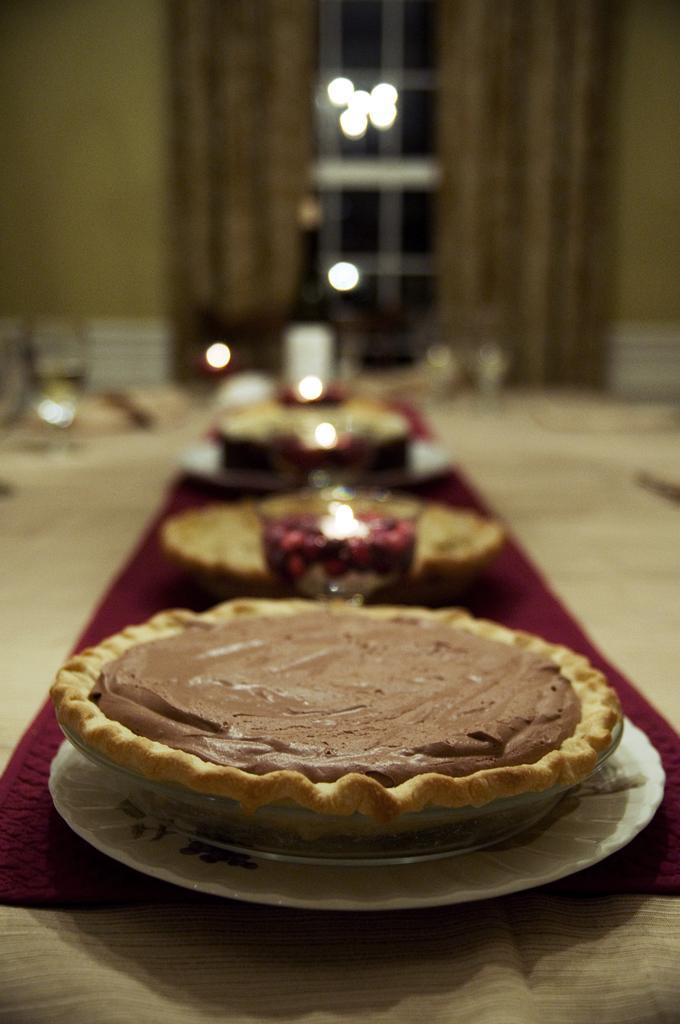Could you give a brief overview of what you see in this image? In this picture, we see a dining table on which plates containing food and glasses containing liquids are placed. In the background, we see a window, curtains and a wall. It is blurred in the background. 